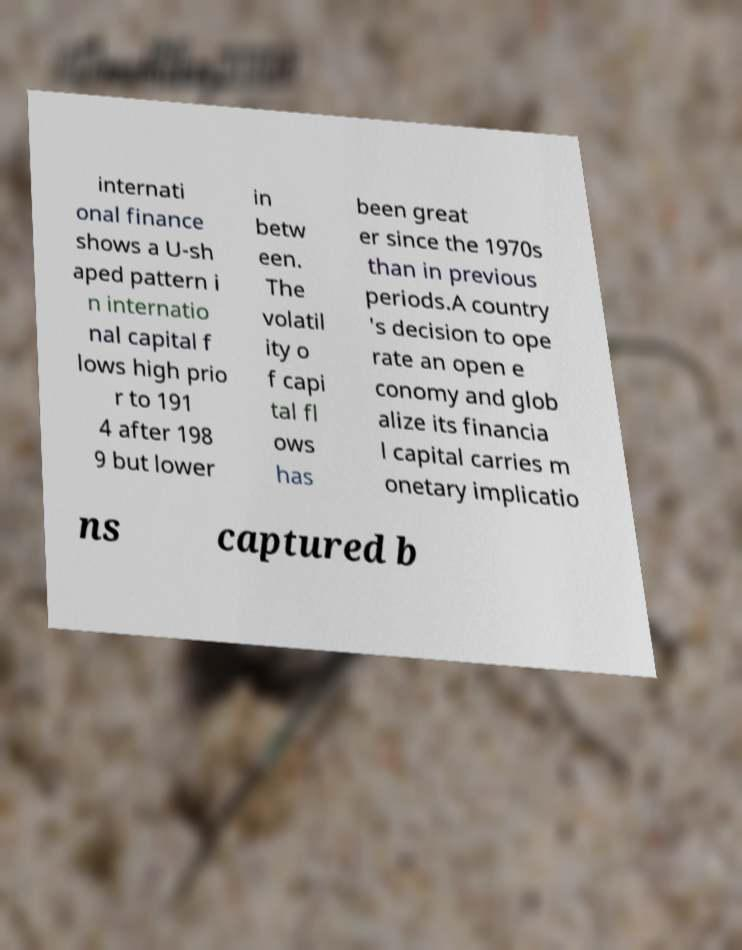Can you read and provide the text displayed in the image?This photo seems to have some interesting text. Can you extract and type it out for me? internati onal finance shows a U-sh aped pattern i n internatio nal capital f lows high prio r to 191 4 after 198 9 but lower in betw een. The volatil ity o f capi tal fl ows has been great er since the 1970s than in previous periods.A country 's decision to ope rate an open e conomy and glob alize its financia l capital carries m onetary implicatio ns captured b 